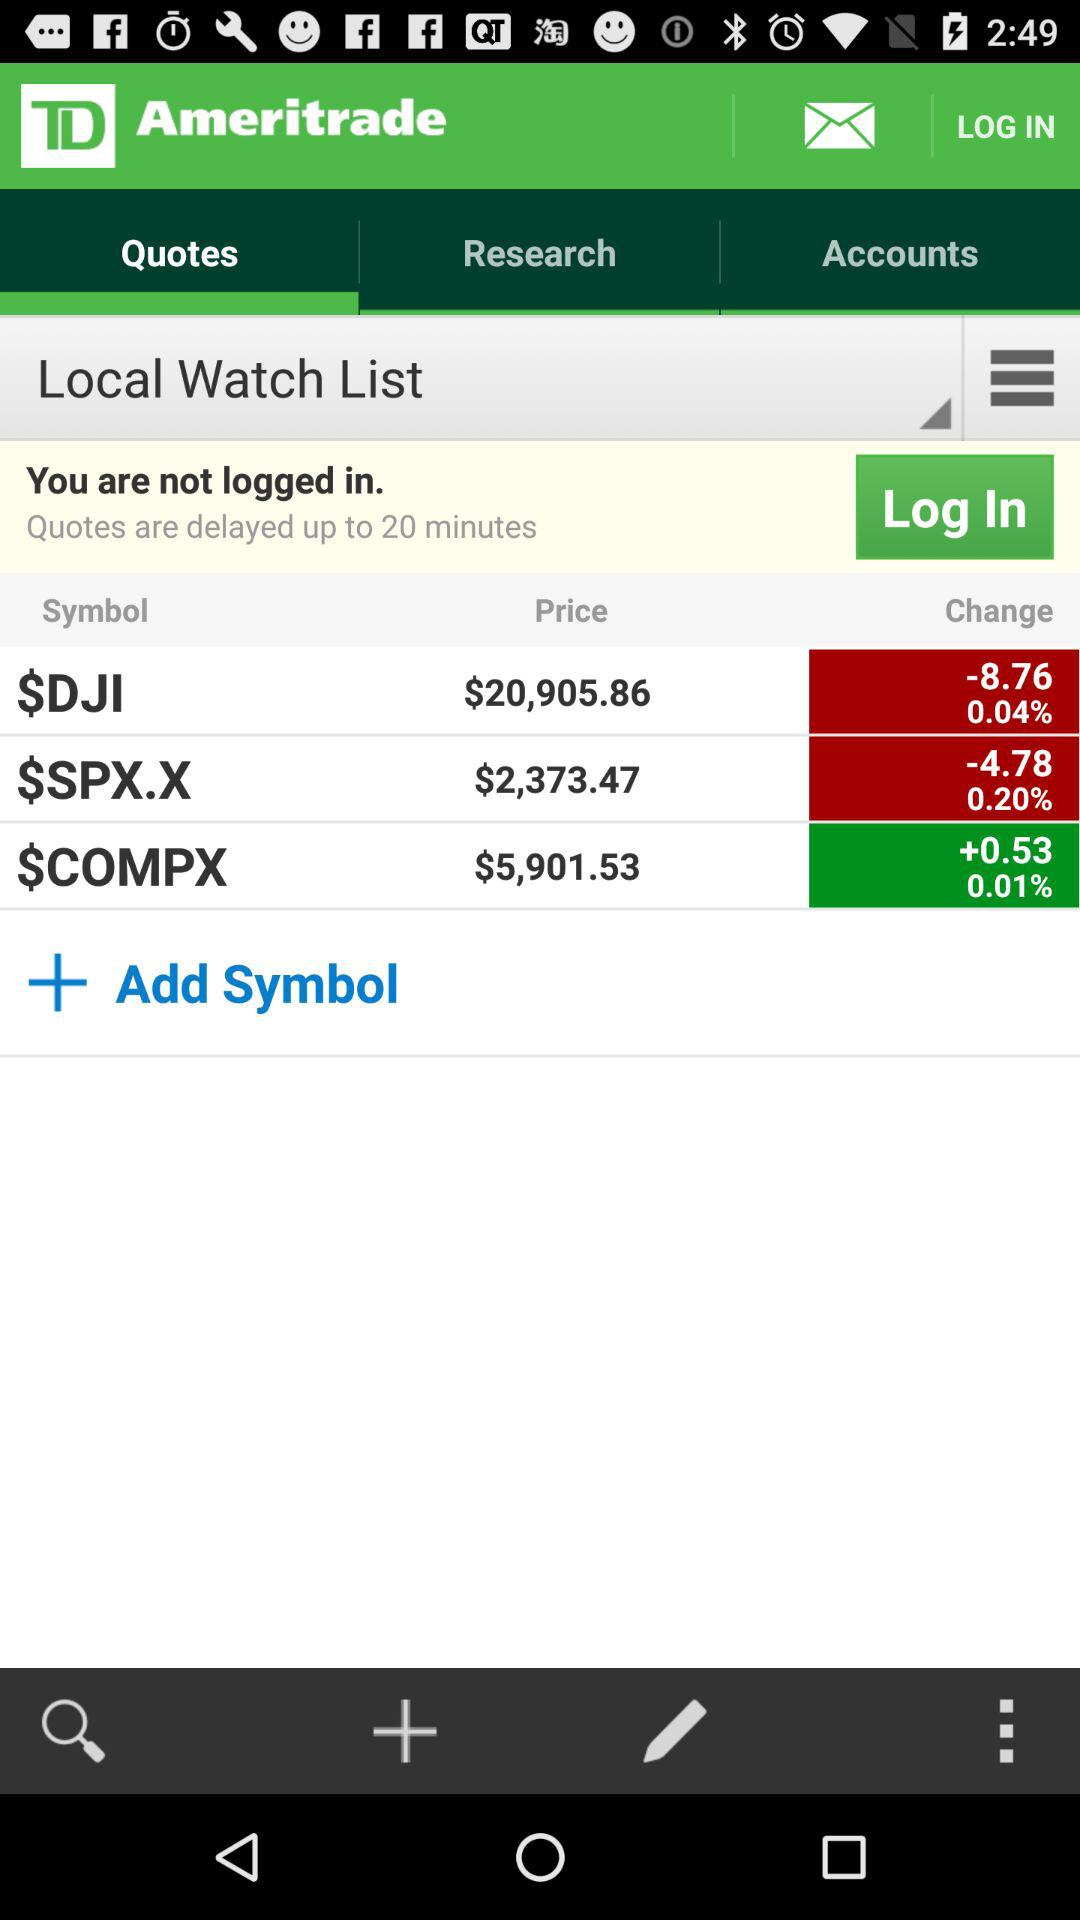How much was DJI at yesterday's close?
When the provided information is insufficient, respond with <no answer>. <no answer> 